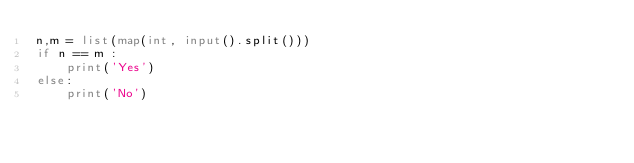Convert code to text. <code><loc_0><loc_0><loc_500><loc_500><_Python_>n,m = list(map(int, input().split())) 
if n == m :
    print('Yes')
else:
    print('No')</code> 